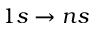Convert formula to latex. <formula><loc_0><loc_0><loc_500><loc_500>1 s \to n s</formula> 